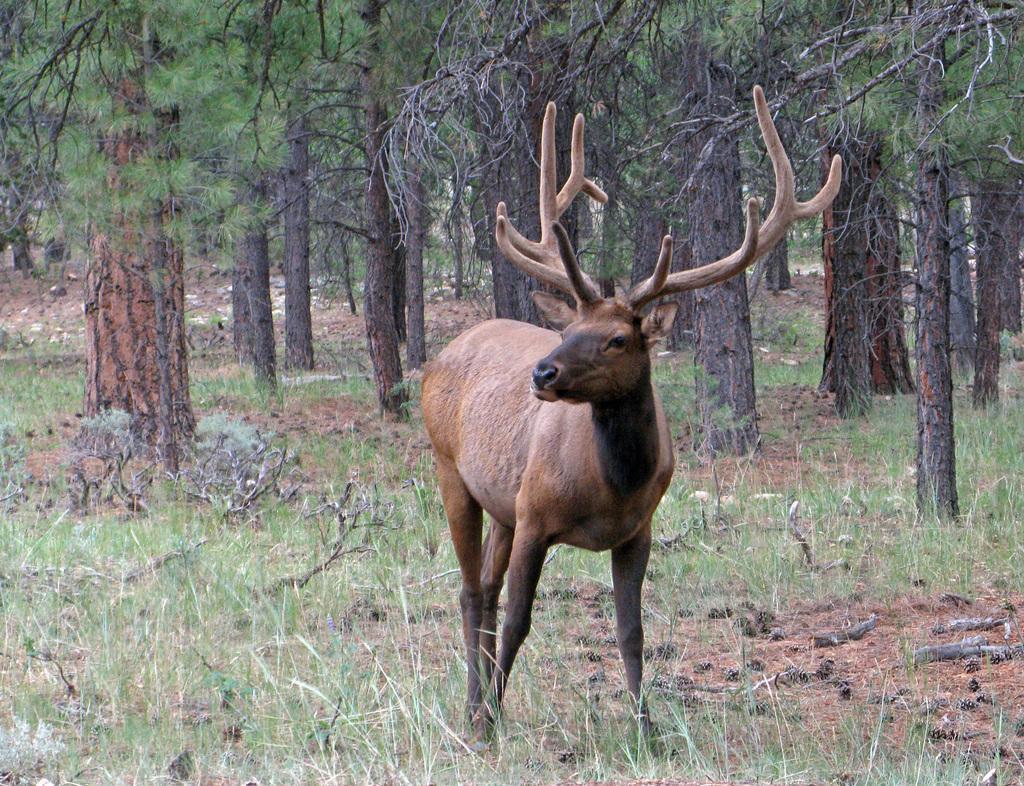Could you give a brief overview of what you see in this image? In this image we can see one animal on the ground in the middle of the image, some trees in the background, some objects on the ground, some dried trees, some stones, some dried sticks and some grass on the ground. 